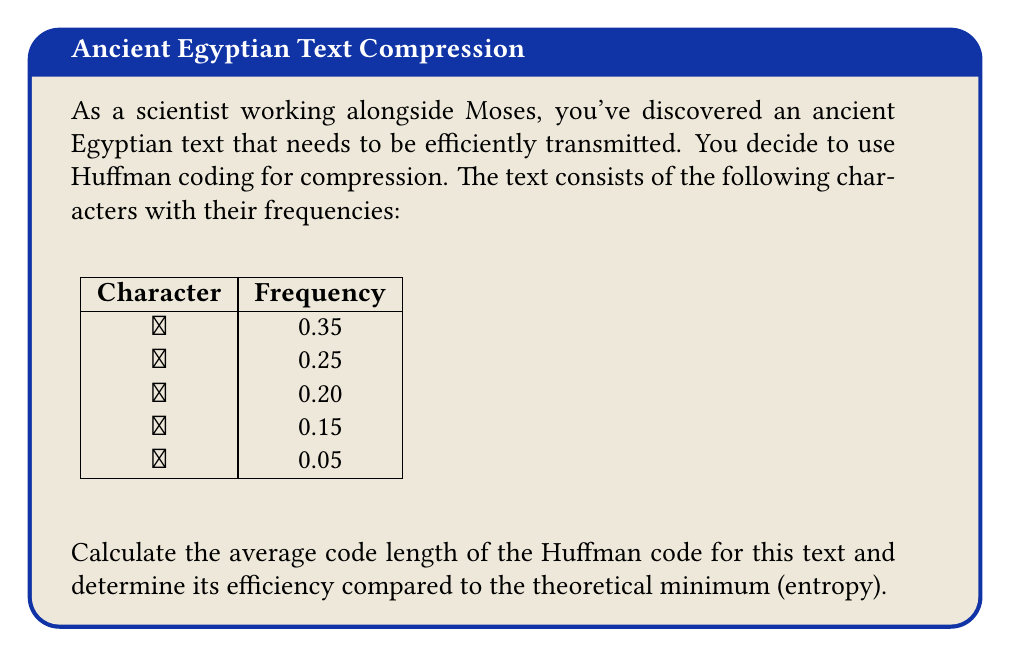Teach me how to tackle this problem. Let's approach this step-by-step:

1) First, we need to construct the Huffman tree:

   - Start with the five nodes: (𓂀, 0.35), (𓃾, 0.25), (𓆣, 0.20), (𓇌, 0.15), (𓈖, 0.05)
   - Combine the two lowest frequencies: (𓈖+𓇌, 0.20)
   - Now we have: (𓂀, 0.35), (𓃾, 0.25), (𓆣, 0.20), (𓈖+𓇌, 0.20)
   - Combine the two lowest again: ((𓈖+𓇌)+𓆣, 0.40)
   - Now: (𓂀, 0.35), (𓃾, 0.25), ((𓈖+𓇌)+𓆣, 0.40)
   - Combine: (𓂀, 0.35), (𓃾+((𓈖+𓇌)+𓆣), 0.65)
   - Final tree: ((𓃾+((𓈖+𓇌)+𓆣))+𓂀, 1.00)

2) The Huffman codes will be:
   𓂀: 0
   𓃾: 10
   𓆣: 110
   𓇌: 1110
   𓈖: 1111

3) Calculate the average code length:
   $L = 0.35(1) + 0.25(2) + 0.20(3) + 0.15(4) + 0.05(4) = 2.15$ bits

4) Calculate the entropy:
   $H = -\sum p_i \log_2 p_i$
   $= -(0.35 \log_2 0.35 + 0.25 \log_2 0.25 + 0.20 \log_2 0.20 + 0.15 \log_2 0.15 + 0.05 \log_2 0.05)$
   $\approx 2.1219$ bits

5) Calculate the efficiency:
   Efficiency = $\frac{H}{L} = \frac{2.1219}{2.15} \approx 0.9869$ or 98.69%
Answer: Average code length: 2.15 bits; Efficiency: 98.69% 